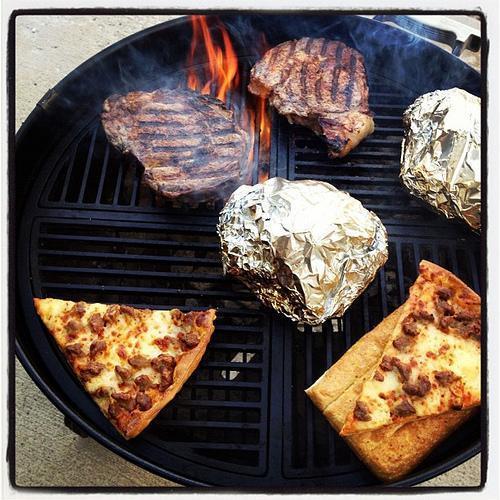How many grates are in the grill?
Give a very brief answer. 4. 